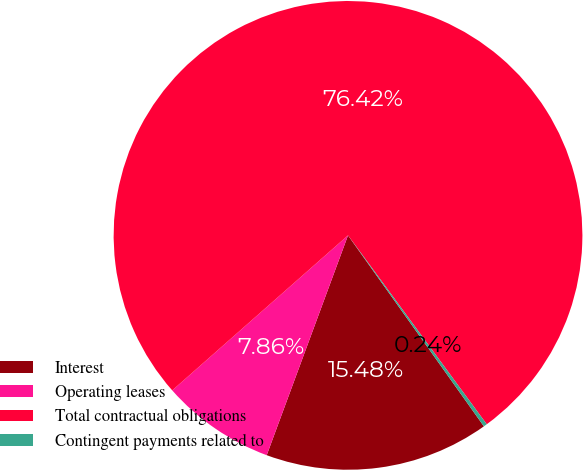Convert chart. <chart><loc_0><loc_0><loc_500><loc_500><pie_chart><fcel>Interest<fcel>Operating leases<fcel>Total contractual obligations<fcel>Contingent payments related to<nl><fcel>15.48%<fcel>7.86%<fcel>76.42%<fcel>0.24%<nl></chart> 